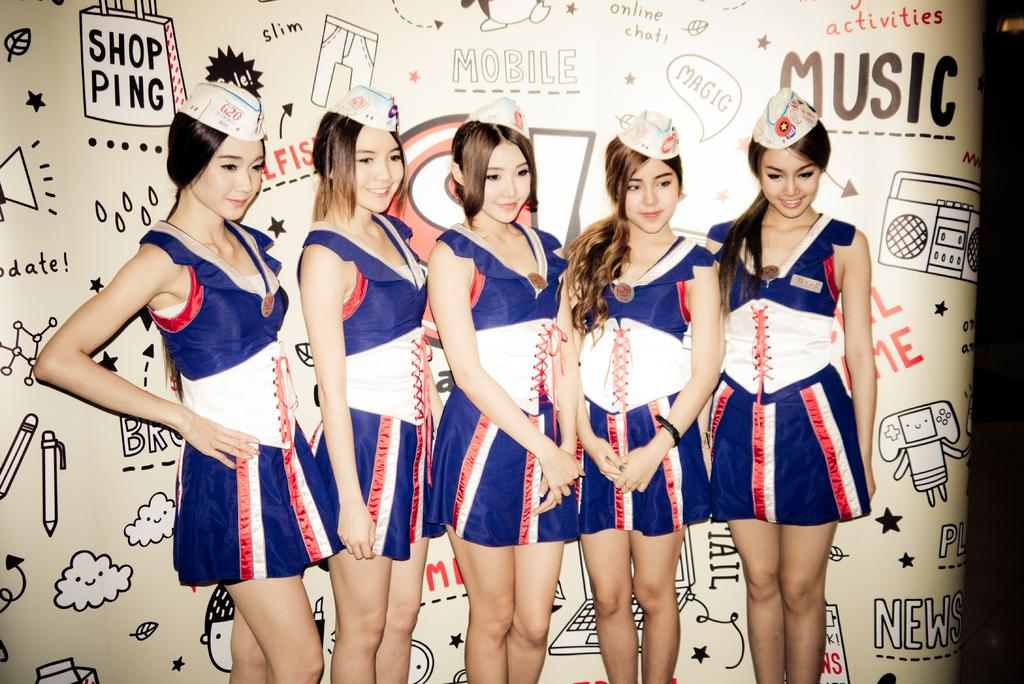<image>
Write a terse but informative summary of the picture. Five girls in uniform stand in front of a wall with doodles and saying such as 'Music', 'MOBILE', and 'SHOPPING' written on it. 